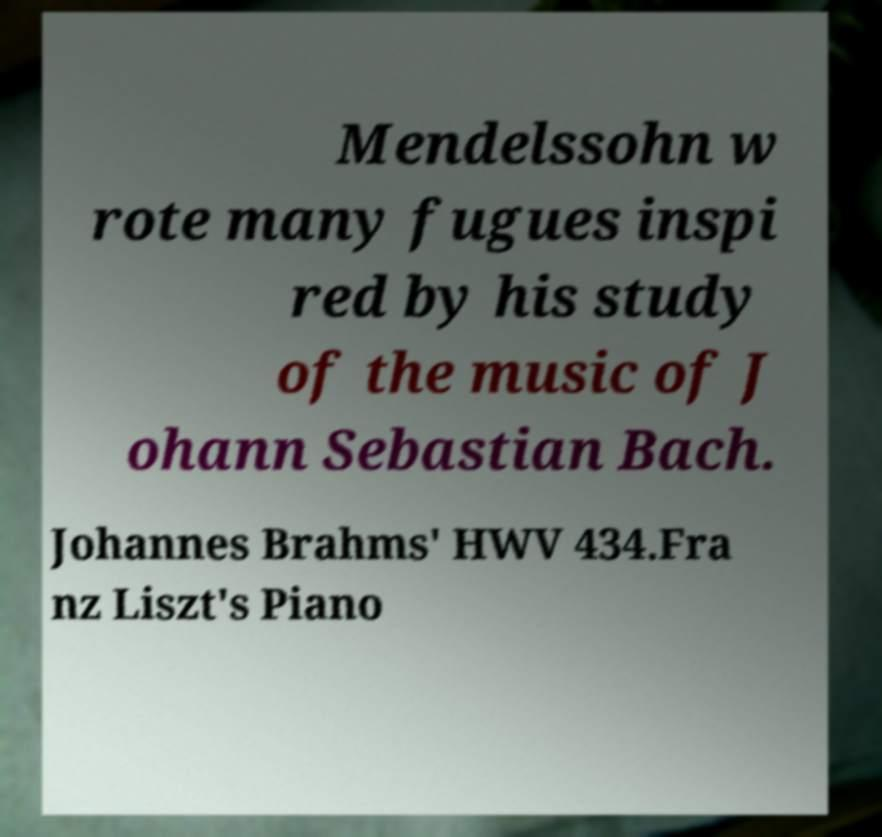I need the written content from this picture converted into text. Can you do that? Mendelssohn w rote many fugues inspi red by his study of the music of J ohann Sebastian Bach. Johannes Brahms' HWV 434.Fra nz Liszt's Piano 